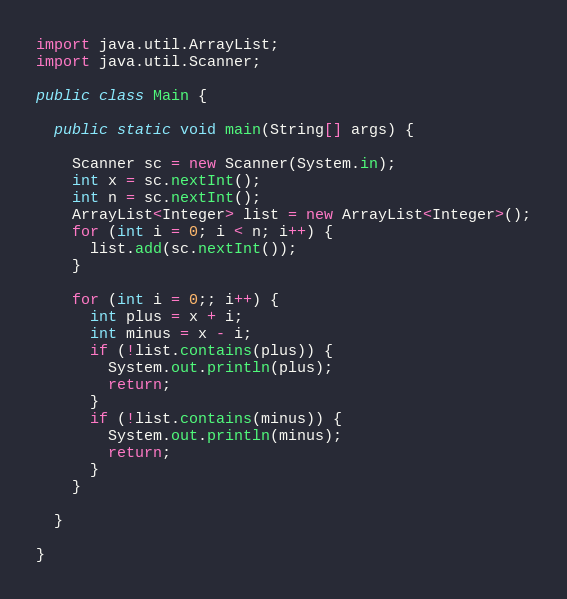Convert code to text. <code><loc_0><loc_0><loc_500><loc_500><_Java_>import java.util.ArrayList;
import java.util.Scanner;

public class Main {

  public static void main(String[] args) {

    Scanner sc = new Scanner(System.in);
    int x = sc.nextInt();
    int n = sc.nextInt();
    ArrayList<Integer> list = new ArrayList<Integer>();
    for (int i = 0; i < n; i++) {
      list.add(sc.nextInt());
    }

    for (int i = 0;; i++) {
      int plus = x + i;
      int minus = x - i;
      if (!list.contains(plus)) {
        System.out.println(plus);
        return;
      }
      if (!list.contains(minus)) {
        System.out.println(minus);
        return;
      }
    }

  }

}</code> 